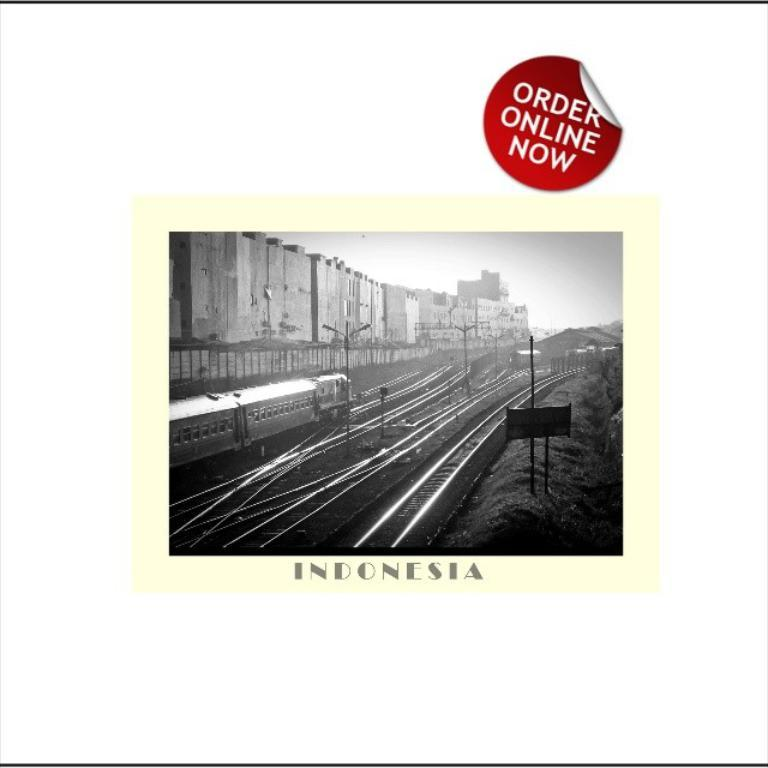<image>
Share a concise interpretation of the image provided. an order online now sign that is for indonesia 